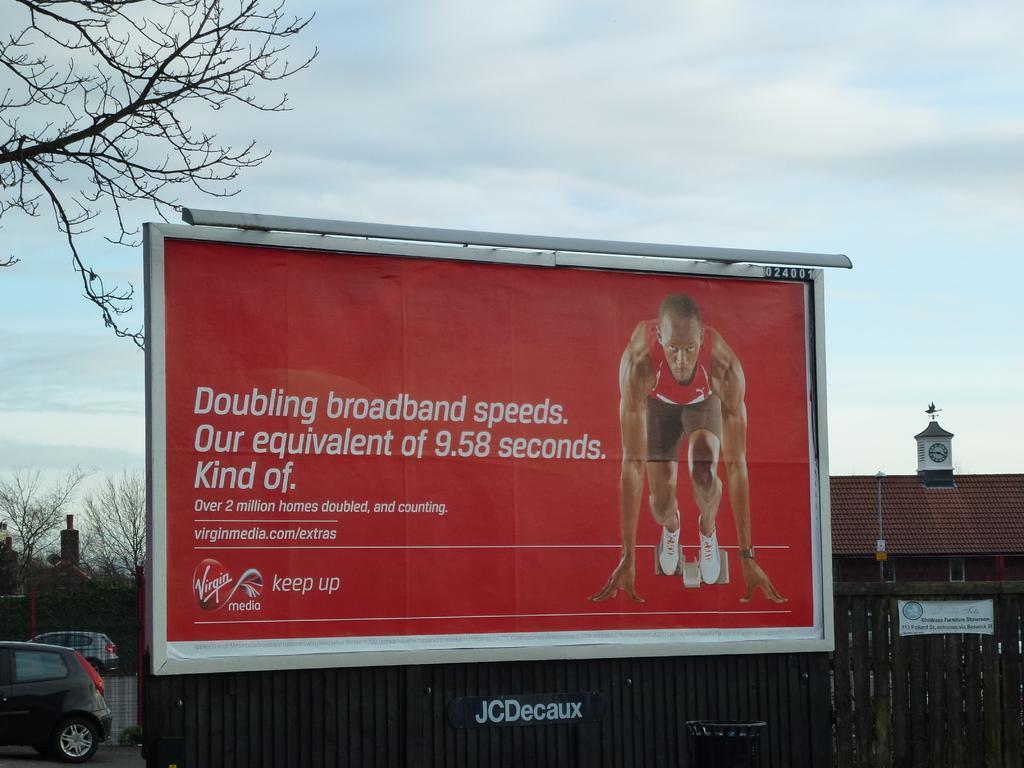Can you describe this image briefly? In this picture there are buildings and there are vehicles and there is a hoarding and there is a picture of a person and text on the hoarding. At the back there are trees. At the top there is sky and there are clouds. In the foreground there is a wooden railing and there is text on the railing. At the bottom there is a road. 